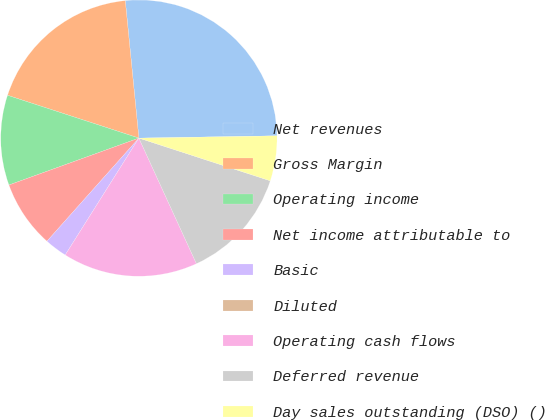Convert chart to OTSL. <chart><loc_0><loc_0><loc_500><loc_500><pie_chart><fcel>Net revenues<fcel>Gross Margin<fcel>Operating income<fcel>Net income attributable to<fcel>Basic<fcel>Diluted<fcel>Operating cash flows<fcel>Deferred revenue<fcel>Day sales outstanding (DSO) ()<nl><fcel>26.31%<fcel>18.42%<fcel>10.53%<fcel>7.9%<fcel>2.64%<fcel>0.0%<fcel>15.79%<fcel>13.16%<fcel>5.27%<nl></chart> 